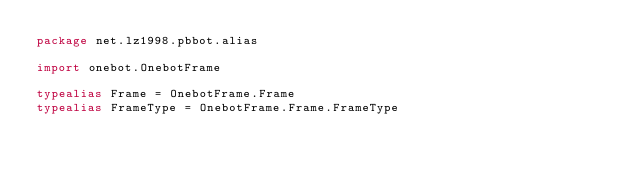<code> <loc_0><loc_0><loc_500><loc_500><_Kotlin_>package net.lz1998.pbbot.alias

import onebot.OnebotFrame

typealias Frame = OnebotFrame.Frame
typealias FrameType = OnebotFrame.Frame.FrameType</code> 